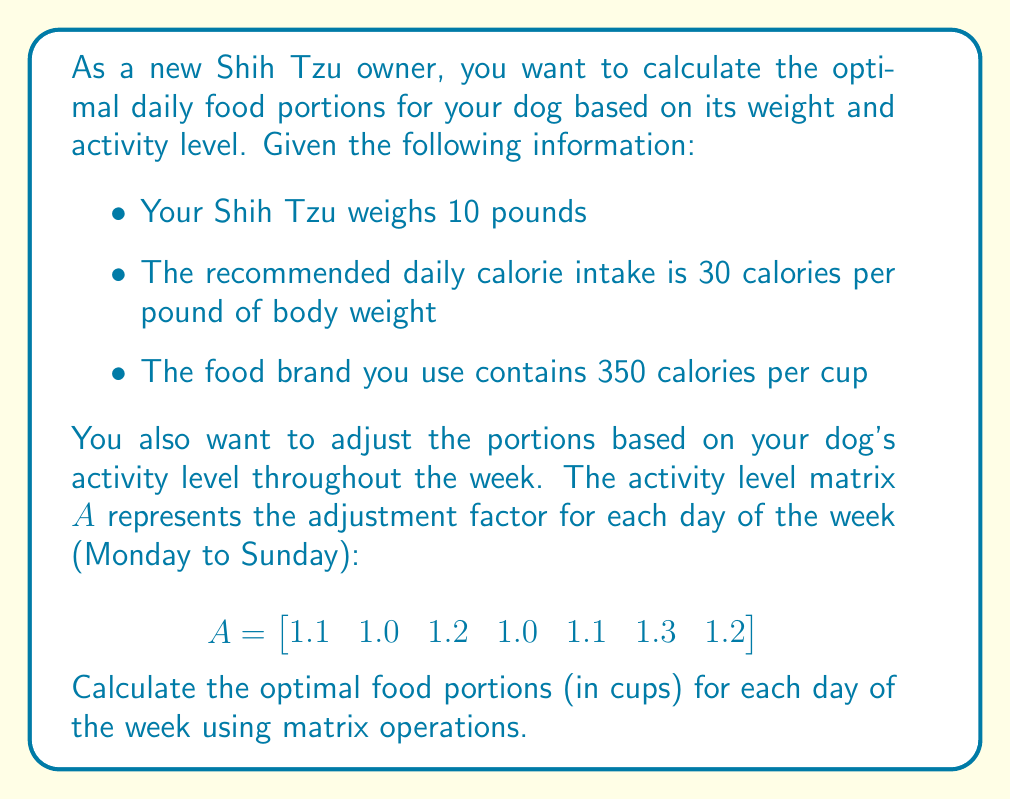Can you answer this question? Let's approach this problem step-by-step using matrix operations:

1. Calculate the daily calorie needs:
   Daily calories = Weight × Calories per pound
   $10 \text{ lbs} \times 30 \text{ cal/lb} = 300 \text{ cal}$

2. Create a base portion matrix $B$ for the week:
   $$B = \begin{bmatrix}
   300 & 300 & 300 & 300 & 300 & 300 & 300
   \end{bmatrix}$$

3. Adjust the base portions using the activity level matrix $A$:
   $$C = A \circ B$$
   where $\circ$ represents element-wise multiplication (Hadamard product).

4. Perform the element-wise multiplication:
   $$C = \begin{bmatrix}
   330 & 300 & 360 & 300 & 330 & 390 & 360
   \end{bmatrix}$$

5. Convert calories to cups by dividing each element by 350 cal/cup:
   $$D = \frac{1}{350} C$$

6. Perform the scalar division:
   $$D = \begin{bmatrix}
   0.943 & 0.857 & 1.029 & 0.857 & 0.943 & 1.114 & 1.029
   \end{bmatrix}$$

The resulting matrix $D$ represents the optimal food portions in cups for each day of the week, from Monday to Sunday.
Answer: The optimal food portions (in cups) for each day of the week, from Monday to Sunday, are:

$$D = \begin{bmatrix}
0.943 & 0.857 & 1.029 & 0.857 & 0.943 & 1.114 & 1.029
\end{bmatrix}$$ 